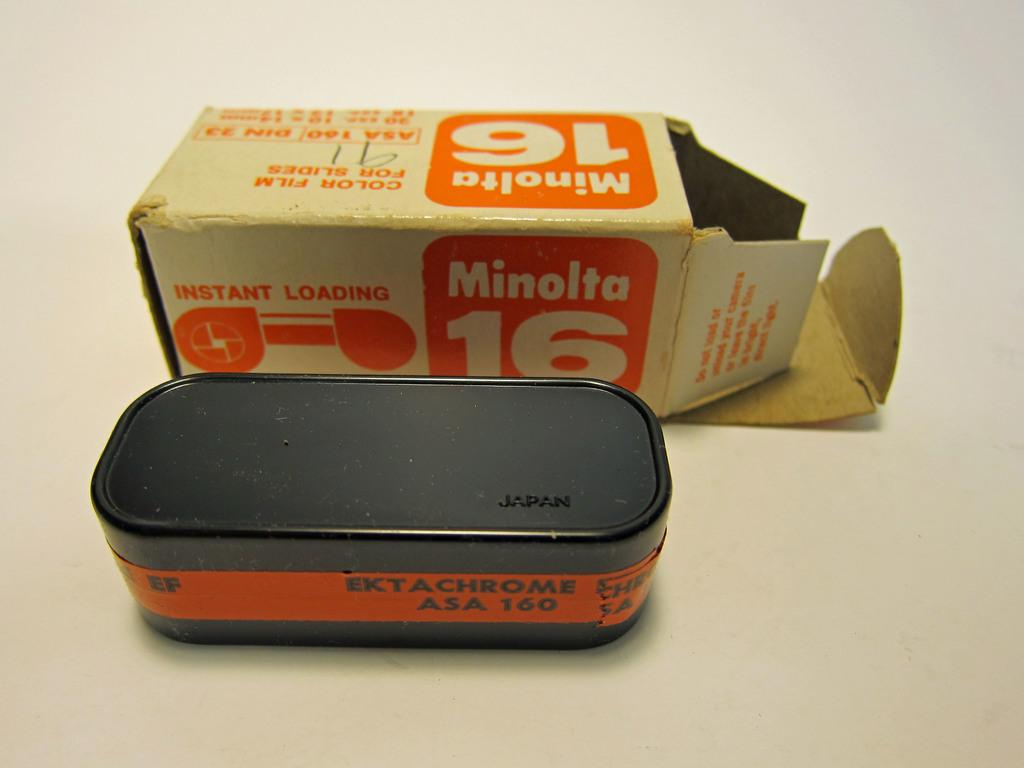<image>
Relay a brief, clear account of the picture shown. A camera, a minolta 16 which was made in Japan, removed from its cardboard box 